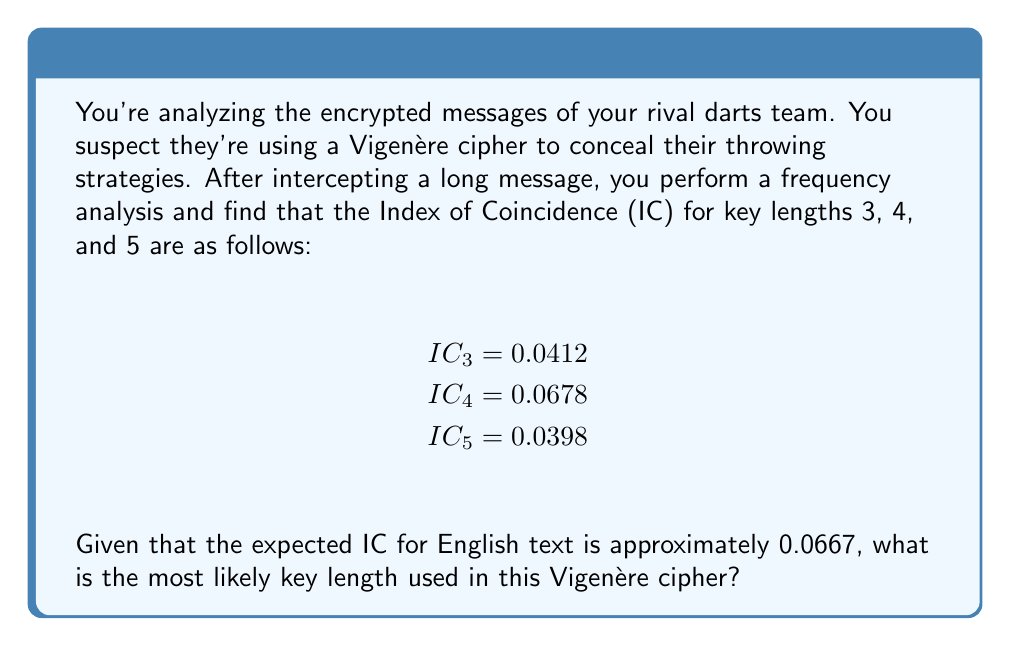Help me with this question. To determine the most likely key length in a Vigenère cipher using frequency analysis, we compare the calculated Index of Coincidence (IC) for different key lengths to the expected IC for the language used (in this case, English).

The Index of Coincidence is a measure of the uniformity of letter frequencies in a text. For a Vigenère cipher, the IC will be closer to that of the original language when the correct key length is used.

Step 1: Recall that the expected IC for English is approximately 0.0667.

Step 2: Compare the given ICs to the expected value:

$IC_3 = 0.0412$ (difference: $|0.0667 - 0.0412| = 0.0255$)
$IC_4 = 0.0678$ (difference: $|0.0667 - 0.0678| = 0.0011$)
$IC_5 = 0.0398$ (difference: $|0.0667 - 0.0398| = 0.0269$)

Step 3: The IC closest to the expected value of 0.0667 is $IC_4 = 0.0678$, with the smallest difference of 0.0011.

Therefore, the most likely key length used in this Vigenère cipher is 4.
Answer: 4 